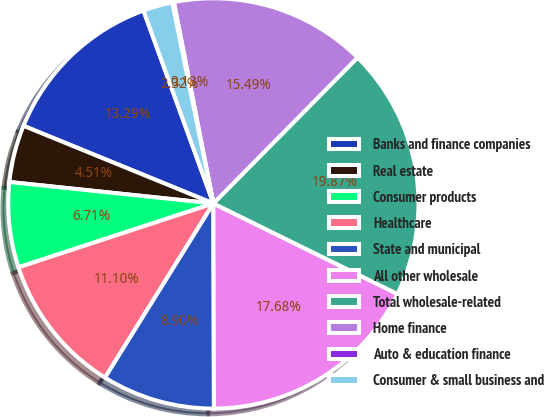<chart> <loc_0><loc_0><loc_500><loc_500><pie_chart><fcel>Banks and finance companies<fcel>Real estate<fcel>Consumer products<fcel>Healthcare<fcel>State and municipal<fcel>All other wholesale<fcel>Total wholesale-related<fcel>Home finance<fcel>Auto & education finance<fcel>Consumer & small business and<nl><fcel>13.29%<fcel>4.51%<fcel>6.71%<fcel>11.1%<fcel>8.9%<fcel>17.68%<fcel>19.87%<fcel>15.49%<fcel>0.13%<fcel>2.32%<nl></chart> 